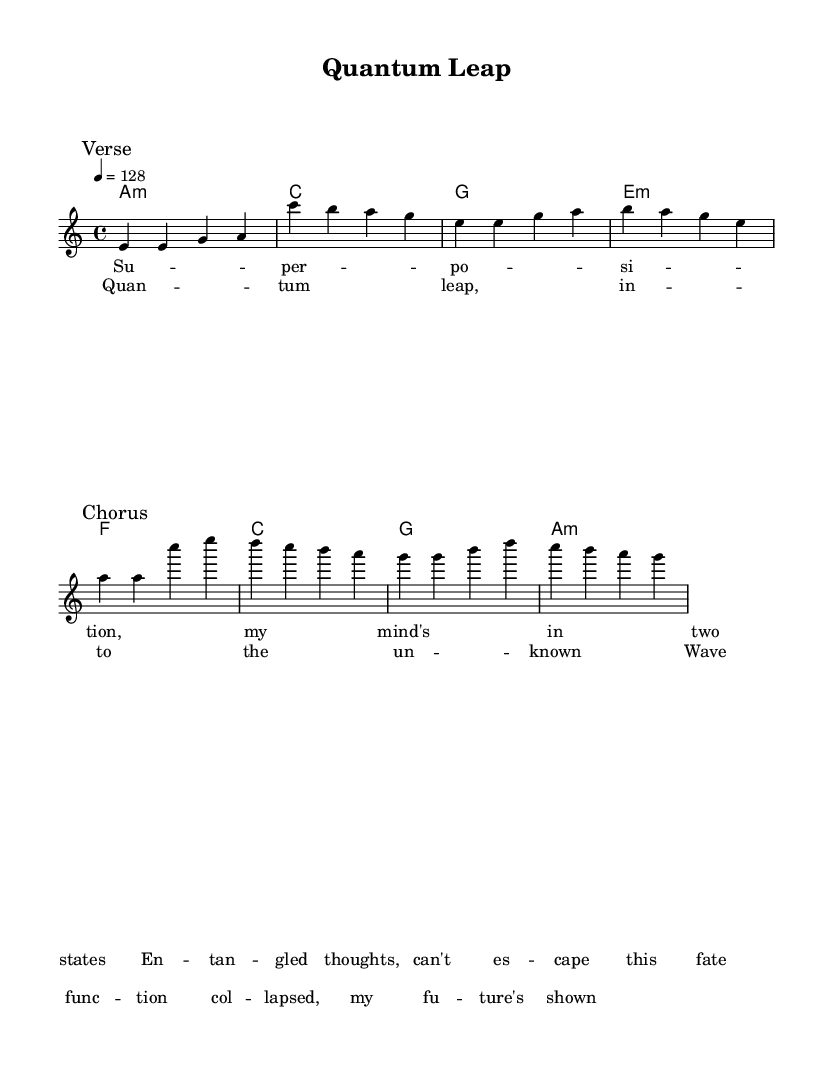What is the key signature of this music? The key signature is indicated at the beginning of the music, showing the key of A minor, which has no sharps or flats.
Answer: A minor What is the time signature of this music? The time signature appears next to the key signature at the beginning, which is 4/4, indicating four beats per measure.
Answer: 4/4 What is the tempo marking for this piece? The tempo marking is found at the start, indicating 128 beats per minute, which specifies the speed of the piece.
Answer: 128 How many measures are in the verse section? The verse section is marked and consists of four measures based on the melody notation before the break.
Answer: 4 What is the tonic chord of this music? The tonic chord represents the key of A minor, which is shown as A minor in the harmonies section.
Answer: A minor What is the overall theme of the lyrics? The lyrics discuss concepts from quantum mechanics, specifically mentioning "superposition" and "entangled thoughts," which relate to theoretical physics.
Answer: Quantum mechanics How does the chorus section differ from the verse section? The chorus section introduces new lyrics and a different melody but maintains the same time signature and key signature, creating a contrast with the verse.
Answer: New lyrics and melody 